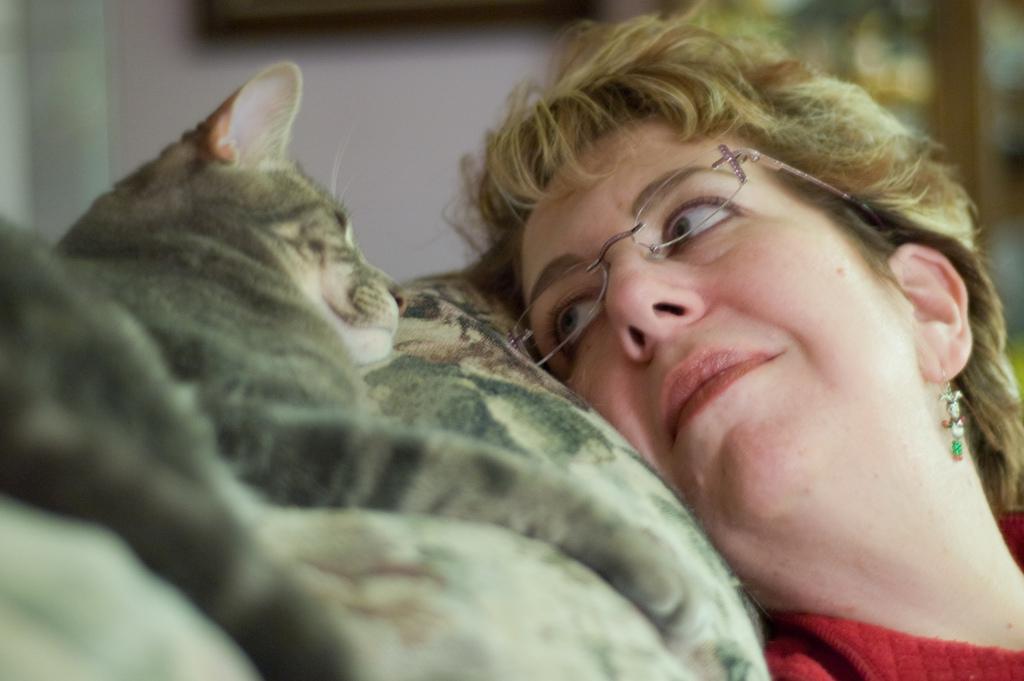In one or two sentences, can you explain what this image depicts? A woman is seeing the cat. 